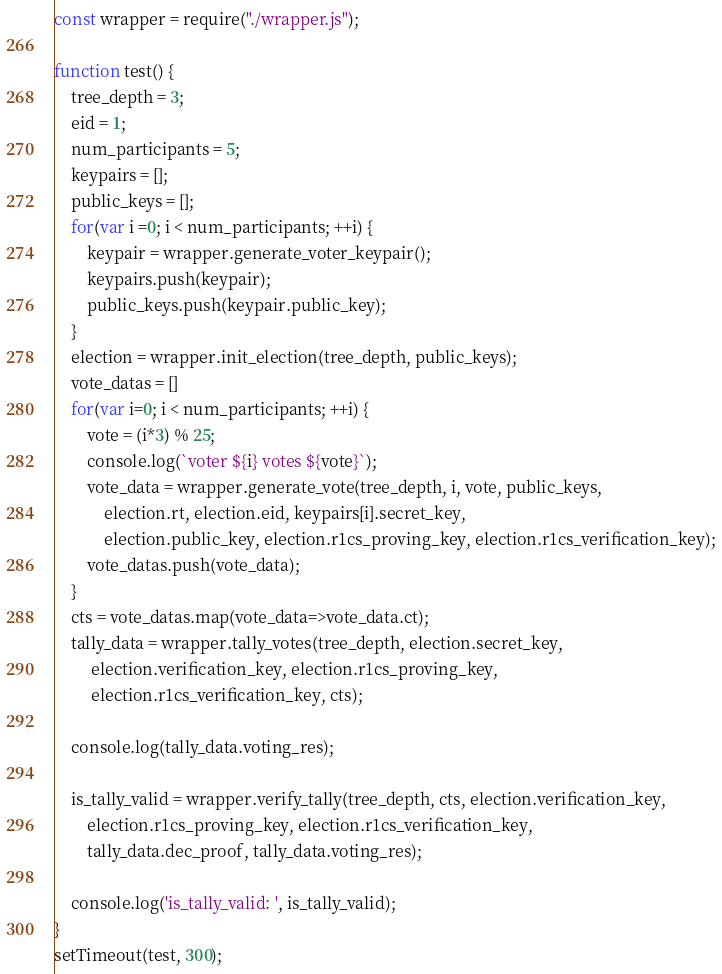<code> <loc_0><loc_0><loc_500><loc_500><_JavaScript_>const wrapper = require("./wrapper.js");

function test() {
    tree_depth = 3;
    eid = 1;
    num_participants = 5;
    keypairs = [];
    public_keys = [];
    for(var i =0; i < num_participants; ++i) {
        keypair = wrapper.generate_voter_keypair();
        keypairs.push(keypair);
        public_keys.push(keypair.public_key);
    }
    election = wrapper.init_election(tree_depth, public_keys);
    vote_datas = []
    for(var i=0; i < num_participants; ++i) {
        vote = (i*3) % 25;
        console.log(`voter ${i} votes ${vote}`);
        vote_data = wrapper.generate_vote(tree_depth, i, vote, public_keys,
            election.rt, election.eid, keypairs[i].secret_key,
            election.public_key, election.r1cs_proving_key, election.r1cs_verification_key);
        vote_datas.push(vote_data);
    }
    cts = vote_datas.map(vote_data=>vote_data.ct);
    tally_data = wrapper.tally_votes(tree_depth, election.secret_key,
         election.verification_key, election.r1cs_proving_key,
         election.r1cs_verification_key, cts);
    
    console.log(tally_data.voting_res);    

    is_tally_valid = wrapper.verify_tally(tree_depth, cts, election.verification_key,
        election.r1cs_proving_key, election.r1cs_verification_key,
        tally_data.dec_proof, tally_data.voting_res);
    
    console.log('is_tally_valid: ', is_tally_valid);
}
setTimeout(test, 300);</code> 